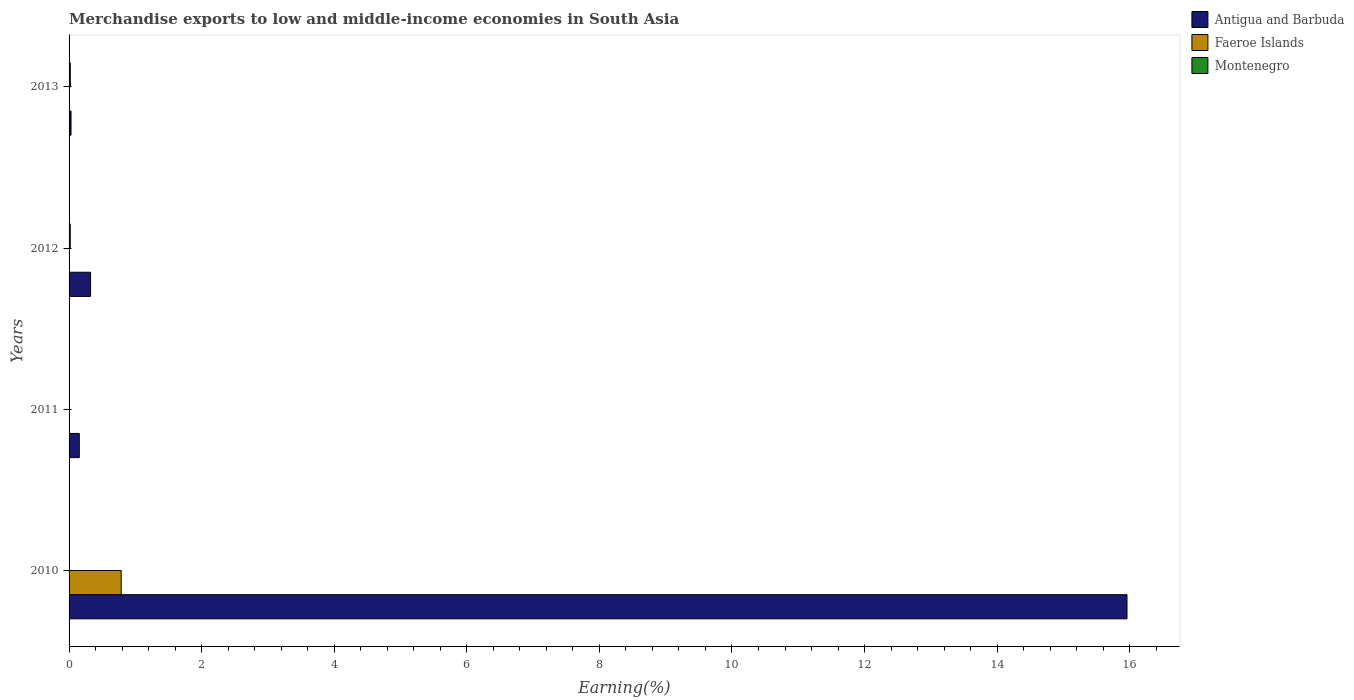How many different coloured bars are there?
Provide a succinct answer. 3. Are the number of bars per tick equal to the number of legend labels?
Your answer should be compact. Yes. How many bars are there on the 3rd tick from the top?
Offer a very short reply. 3. How many bars are there on the 1st tick from the bottom?
Keep it short and to the point. 3. What is the label of the 4th group of bars from the top?
Your answer should be very brief. 2010. In how many cases, is the number of bars for a given year not equal to the number of legend labels?
Provide a short and direct response. 0. What is the percentage of amount earned from merchandise exports in Antigua and Barbuda in 2010?
Provide a succinct answer. 15.96. Across all years, what is the maximum percentage of amount earned from merchandise exports in Montenegro?
Give a very brief answer. 0.02. Across all years, what is the minimum percentage of amount earned from merchandise exports in Montenegro?
Your answer should be compact. 0. In which year was the percentage of amount earned from merchandise exports in Montenegro maximum?
Give a very brief answer. 2013. What is the total percentage of amount earned from merchandise exports in Faeroe Islands in the graph?
Provide a succinct answer. 0.79. What is the difference between the percentage of amount earned from merchandise exports in Faeroe Islands in 2010 and that in 2013?
Your answer should be compact. 0.79. What is the difference between the percentage of amount earned from merchandise exports in Antigua and Barbuda in 2010 and the percentage of amount earned from merchandise exports in Faeroe Islands in 2012?
Provide a short and direct response. 15.96. What is the average percentage of amount earned from merchandise exports in Antigua and Barbuda per year?
Offer a very short reply. 4.12. In the year 2011, what is the difference between the percentage of amount earned from merchandise exports in Faeroe Islands and percentage of amount earned from merchandise exports in Montenegro?
Ensure brevity in your answer.  -0. What is the ratio of the percentage of amount earned from merchandise exports in Montenegro in 2010 to that in 2011?
Offer a terse response. 0.04. What is the difference between the highest and the second highest percentage of amount earned from merchandise exports in Montenegro?
Keep it short and to the point. 0. What is the difference between the highest and the lowest percentage of amount earned from merchandise exports in Antigua and Barbuda?
Offer a very short reply. 15.93. What does the 1st bar from the top in 2012 represents?
Your answer should be compact. Montenegro. What does the 3rd bar from the bottom in 2010 represents?
Ensure brevity in your answer.  Montenegro. Is it the case that in every year, the sum of the percentage of amount earned from merchandise exports in Montenegro and percentage of amount earned from merchandise exports in Antigua and Barbuda is greater than the percentage of amount earned from merchandise exports in Faeroe Islands?
Keep it short and to the point. Yes. How many bars are there?
Make the answer very short. 12. How many years are there in the graph?
Your answer should be very brief. 4. What is the difference between two consecutive major ticks on the X-axis?
Offer a very short reply. 2. Are the values on the major ticks of X-axis written in scientific E-notation?
Ensure brevity in your answer.  No. How are the legend labels stacked?
Your response must be concise. Vertical. What is the title of the graph?
Keep it short and to the point. Merchandise exports to low and middle-income economies in South Asia. What is the label or title of the X-axis?
Your answer should be compact. Earning(%). What is the label or title of the Y-axis?
Ensure brevity in your answer.  Years. What is the Earning(%) in Antigua and Barbuda in 2010?
Keep it short and to the point. 15.96. What is the Earning(%) of Faeroe Islands in 2010?
Keep it short and to the point. 0.79. What is the Earning(%) in Montenegro in 2010?
Your response must be concise. 0. What is the Earning(%) in Antigua and Barbuda in 2011?
Your response must be concise. 0.15. What is the Earning(%) in Faeroe Islands in 2011?
Ensure brevity in your answer.  0. What is the Earning(%) in Montenegro in 2011?
Offer a very short reply. 0. What is the Earning(%) of Antigua and Barbuda in 2012?
Your response must be concise. 0.32. What is the Earning(%) of Faeroe Islands in 2012?
Your answer should be very brief. 1.9199162385165e-5. What is the Earning(%) in Montenegro in 2012?
Offer a very short reply. 0.02. What is the Earning(%) in Antigua and Barbuda in 2013?
Offer a terse response. 0.03. What is the Earning(%) in Faeroe Islands in 2013?
Provide a short and direct response. 3.45425076953635e-5. What is the Earning(%) of Montenegro in 2013?
Your response must be concise. 0.02. Across all years, what is the maximum Earning(%) of Antigua and Barbuda?
Offer a very short reply. 15.96. Across all years, what is the maximum Earning(%) in Faeroe Islands?
Ensure brevity in your answer.  0.79. Across all years, what is the maximum Earning(%) of Montenegro?
Keep it short and to the point. 0.02. Across all years, what is the minimum Earning(%) of Antigua and Barbuda?
Offer a very short reply. 0.03. Across all years, what is the minimum Earning(%) in Faeroe Islands?
Your answer should be very brief. 1.9199162385165e-5. Across all years, what is the minimum Earning(%) of Montenegro?
Make the answer very short. 0. What is the total Earning(%) of Antigua and Barbuda in the graph?
Give a very brief answer. 16.47. What is the total Earning(%) of Faeroe Islands in the graph?
Give a very brief answer. 0.79. What is the total Earning(%) in Montenegro in the graph?
Keep it short and to the point. 0.04. What is the difference between the Earning(%) in Antigua and Barbuda in 2010 and that in 2011?
Provide a succinct answer. 15.8. What is the difference between the Earning(%) in Faeroe Islands in 2010 and that in 2011?
Ensure brevity in your answer.  0.78. What is the difference between the Earning(%) of Montenegro in 2010 and that in 2011?
Your response must be concise. -0. What is the difference between the Earning(%) of Antigua and Barbuda in 2010 and that in 2012?
Your answer should be compact. 15.63. What is the difference between the Earning(%) of Faeroe Islands in 2010 and that in 2012?
Provide a short and direct response. 0.79. What is the difference between the Earning(%) in Montenegro in 2010 and that in 2012?
Provide a short and direct response. -0.02. What is the difference between the Earning(%) of Antigua and Barbuda in 2010 and that in 2013?
Provide a succinct answer. 15.93. What is the difference between the Earning(%) of Faeroe Islands in 2010 and that in 2013?
Your answer should be compact. 0.79. What is the difference between the Earning(%) in Montenegro in 2010 and that in 2013?
Ensure brevity in your answer.  -0.02. What is the difference between the Earning(%) of Antigua and Barbuda in 2011 and that in 2012?
Offer a very short reply. -0.17. What is the difference between the Earning(%) of Faeroe Islands in 2011 and that in 2012?
Your answer should be compact. 0. What is the difference between the Earning(%) of Montenegro in 2011 and that in 2012?
Your answer should be very brief. -0.01. What is the difference between the Earning(%) of Antigua and Barbuda in 2011 and that in 2013?
Make the answer very short. 0.12. What is the difference between the Earning(%) of Faeroe Islands in 2011 and that in 2013?
Provide a short and direct response. 0. What is the difference between the Earning(%) of Montenegro in 2011 and that in 2013?
Offer a terse response. -0.01. What is the difference between the Earning(%) of Antigua and Barbuda in 2012 and that in 2013?
Your answer should be very brief. 0.29. What is the difference between the Earning(%) in Faeroe Islands in 2012 and that in 2013?
Provide a succinct answer. -0. What is the difference between the Earning(%) in Montenegro in 2012 and that in 2013?
Offer a very short reply. -0. What is the difference between the Earning(%) in Antigua and Barbuda in 2010 and the Earning(%) in Faeroe Islands in 2011?
Make the answer very short. 15.96. What is the difference between the Earning(%) of Antigua and Barbuda in 2010 and the Earning(%) of Montenegro in 2011?
Offer a terse response. 15.95. What is the difference between the Earning(%) in Faeroe Islands in 2010 and the Earning(%) in Montenegro in 2011?
Your answer should be compact. 0.78. What is the difference between the Earning(%) of Antigua and Barbuda in 2010 and the Earning(%) of Faeroe Islands in 2012?
Make the answer very short. 15.96. What is the difference between the Earning(%) of Antigua and Barbuda in 2010 and the Earning(%) of Montenegro in 2012?
Make the answer very short. 15.94. What is the difference between the Earning(%) of Faeroe Islands in 2010 and the Earning(%) of Montenegro in 2012?
Offer a terse response. 0.77. What is the difference between the Earning(%) of Antigua and Barbuda in 2010 and the Earning(%) of Faeroe Islands in 2013?
Make the answer very short. 15.96. What is the difference between the Earning(%) of Antigua and Barbuda in 2010 and the Earning(%) of Montenegro in 2013?
Offer a terse response. 15.94. What is the difference between the Earning(%) of Faeroe Islands in 2010 and the Earning(%) of Montenegro in 2013?
Your response must be concise. 0.77. What is the difference between the Earning(%) of Antigua and Barbuda in 2011 and the Earning(%) of Faeroe Islands in 2012?
Offer a terse response. 0.15. What is the difference between the Earning(%) of Antigua and Barbuda in 2011 and the Earning(%) of Montenegro in 2012?
Your answer should be very brief. 0.14. What is the difference between the Earning(%) of Faeroe Islands in 2011 and the Earning(%) of Montenegro in 2012?
Offer a terse response. -0.01. What is the difference between the Earning(%) of Antigua and Barbuda in 2011 and the Earning(%) of Faeroe Islands in 2013?
Provide a short and direct response. 0.15. What is the difference between the Earning(%) in Antigua and Barbuda in 2011 and the Earning(%) in Montenegro in 2013?
Keep it short and to the point. 0.14. What is the difference between the Earning(%) of Faeroe Islands in 2011 and the Earning(%) of Montenegro in 2013?
Offer a terse response. -0.02. What is the difference between the Earning(%) in Antigua and Barbuda in 2012 and the Earning(%) in Faeroe Islands in 2013?
Ensure brevity in your answer.  0.32. What is the difference between the Earning(%) of Antigua and Barbuda in 2012 and the Earning(%) of Montenegro in 2013?
Your answer should be compact. 0.31. What is the difference between the Earning(%) in Faeroe Islands in 2012 and the Earning(%) in Montenegro in 2013?
Provide a succinct answer. -0.02. What is the average Earning(%) of Antigua and Barbuda per year?
Provide a short and direct response. 4.12. What is the average Earning(%) in Faeroe Islands per year?
Provide a succinct answer. 0.2. What is the average Earning(%) in Montenegro per year?
Your answer should be compact. 0.01. In the year 2010, what is the difference between the Earning(%) of Antigua and Barbuda and Earning(%) of Faeroe Islands?
Provide a short and direct response. 15.17. In the year 2010, what is the difference between the Earning(%) of Antigua and Barbuda and Earning(%) of Montenegro?
Your response must be concise. 15.96. In the year 2010, what is the difference between the Earning(%) in Faeroe Islands and Earning(%) in Montenegro?
Provide a short and direct response. 0.79. In the year 2011, what is the difference between the Earning(%) in Antigua and Barbuda and Earning(%) in Faeroe Islands?
Your response must be concise. 0.15. In the year 2011, what is the difference between the Earning(%) in Antigua and Barbuda and Earning(%) in Montenegro?
Your answer should be very brief. 0.15. In the year 2011, what is the difference between the Earning(%) in Faeroe Islands and Earning(%) in Montenegro?
Ensure brevity in your answer.  -0. In the year 2012, what is the difference between the Earning(%) in Antigua and Barbuda and Earning(%) in Faeroe Islands?
Give a very brief answer. 0.32. In the year 2012, what is the difference between the Earning(%) of Antigua and Barbuda and Earning(%) of Montenegro?
Your answer should be very brief. 0.31. In the year 2012, what is the difference between the Earning(%) of Faeroe Islands and Earning(%) of Montenegro?
Provide a succinct answer. -0.02. In the year 2013, what is the difference between the Earning(%) in Antigua and Barbuda and Earning(%) in Faeroe Islands?
Offer a terse response. 0.03. In the year 2013, what is the difference between the Earning(%) of Antigua and Barbuda and Earning(%) of Montenegro?
Your response must be concise. 0.01. In the year 2013, what is the difference between the Earning(%) of Faeroe Islands and Earning(%) of Montenegro?
Offer a very short reply. -0.02. What is the ratio of the Earning(%) of Antigua and Barbuda in 2010 to that in 2011?
Your answer should be compact. 103.47. What is the ratio of the Earning(%) of Faeroe Islands in 2010 to that in 2011?
Provide a short and direct response. 228.91. What is the ratio of the Earning(%) of Montenegro in 2010 to that in 2011?
Make the answer very short. 0.04. What is the ratio of the Earning(%) of Antigua and Barbuda in 2010 to that in 2012?
Offer a terse response. 49.21. What is the ratio of the Earning(%) in Faeroe Islands in 2010 to that in 2012?
Offer a very short reply. 4.10e+04. What is the ratio of the Earning(%) of Montenegro in 2010 to that in 2012?
Your answer should be very brief. 0.01. What is the ratio of the Earning(%) in Antigua and Barbuda in 2010 to that in 2013?
Provide a short and direct response. 541.3. What is the ratio of the Earning(%) in Faeroe Islands in 2010 to that in 2013?
Ensure brevity in your answer.  2.28e+04. What is the ratio of the Earning(%) in Montenegro in 2010 to that in 2013?
Give a very brief answer. 0.01. What is the ratio of the Earning(%) of Antigua and Barbuda in 2011 to that in 2012?
Your response must be concise. 0.48. What is the ratio of the Earning(%) of Faeroe Islands in 2011 to that in 2012?
Provide a short and direct response. 178.97. What is the ratio of the Earning(%) of Montenegro in 2011 to that in 2012?
Provide a short and direct response. 0.25. What is the ratio of the Earning(%) in Antigua and Barbuda in 2011 to that in 2013?
Your response must be concise. 5.23. What is the ratio of the Earning(%) in Faeroe Islands in 2011 to that in 2013?
Make the answer very short. 99.47. What is the ratio of the Earning(%) in Montenegro in 2011 to that in 2013?
Offer a very short reply. 0.23. What is the ratio of the Earning(%) of Antigua and Barbuda in 2012 to that in 2013?
Your answer should be very brief. 11. What is the ratio of the Earning(%) in Faeroe Islands in 2012 to that in 2013?
Ensure brevity in your answer.  0.56. What is the ratio of the Earning(%) in Montenegro in 2012 to that in 2013?
Provide a short and direct response. 0.93. What is the difference between the highest and the second highest Earning(%) of Antigua and Barbuda?
Provide a succinct answer. 15.63. What is the difference between the highest and the second highest Earning(%) in Faeroe Islands?
Provide a succinct answer. 0.78. What is the difference between the highest and the second highest Earning(%) in Montenegro?
Provide a succinct answer. 0. What is the difference between the highest and the lowest Earning(%) of Antigua and Barbuda?
Your answer should be very brief. 15.93. What is the difference between the highest and the lowest Earning(%) of Faeroe Islands?
Make the answer very short. 0.79. What is the difference between the highest and the lowest Earning(%) of Montenegro?
Ensure brevity in your answer.  0.02. 